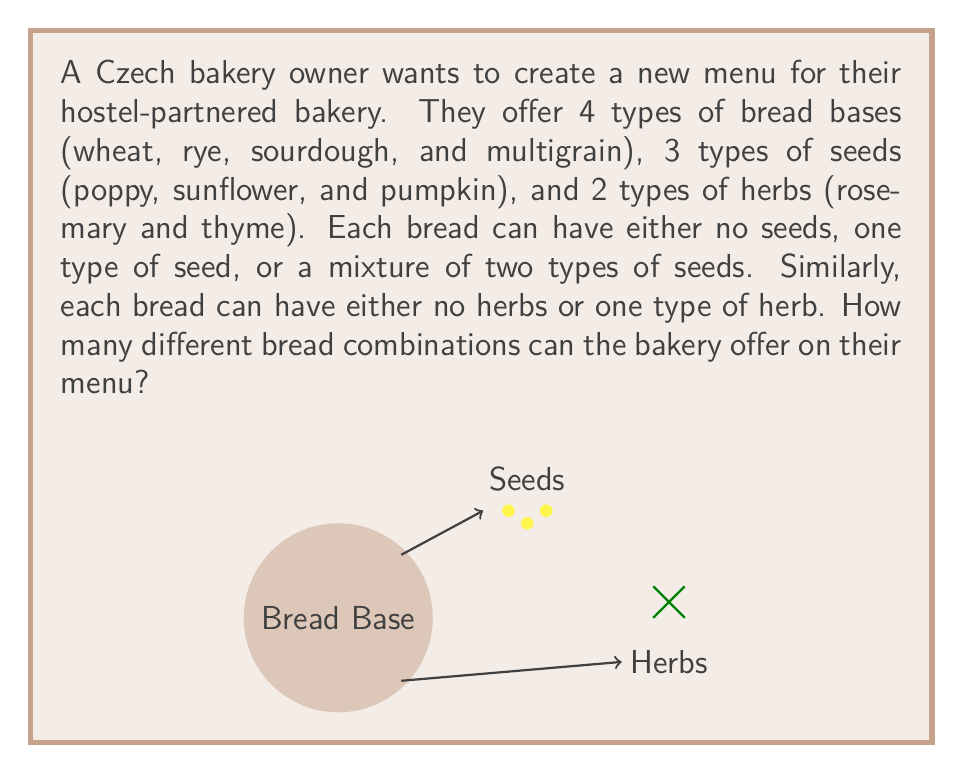Provide a solution to this math problem. Let's break this down step-by-step:

1) First, let's consider the bread bases:
   There are 4 types of bread bases.

2) Now, let's consider the seed options:
   - No seeds: 1 option
   - One type of seed: 3 options (poppy, sunflower, or pumpkin)
   - Two types of seeds: $\binom{3}{2} = 3$ options (poppy+sunflower, poppy+pumpkin, sunflower+pumpkin)
   Total seed options: $1 + 3 + 3 = 7$

3) For herbs, we have:
   - No herbs: 1 option
   - One herb: 2 options (rosemary or thyme)
   Total herb options: $1 + 2 = 3$

4) Now, we can use the multiplication principle. For each bread base, we can choose any of the seed options and any of the herb options independently.

5) Therefore, the total number of combinations is:
   $$ 4 \text{ (bread bases)} \times 7 \text{ (seed options)} \times 3 \text{ (herb options)} = 84 $$

Thus, the bakery can offer 84 different bread combinations on their menu.
Answer: 84 